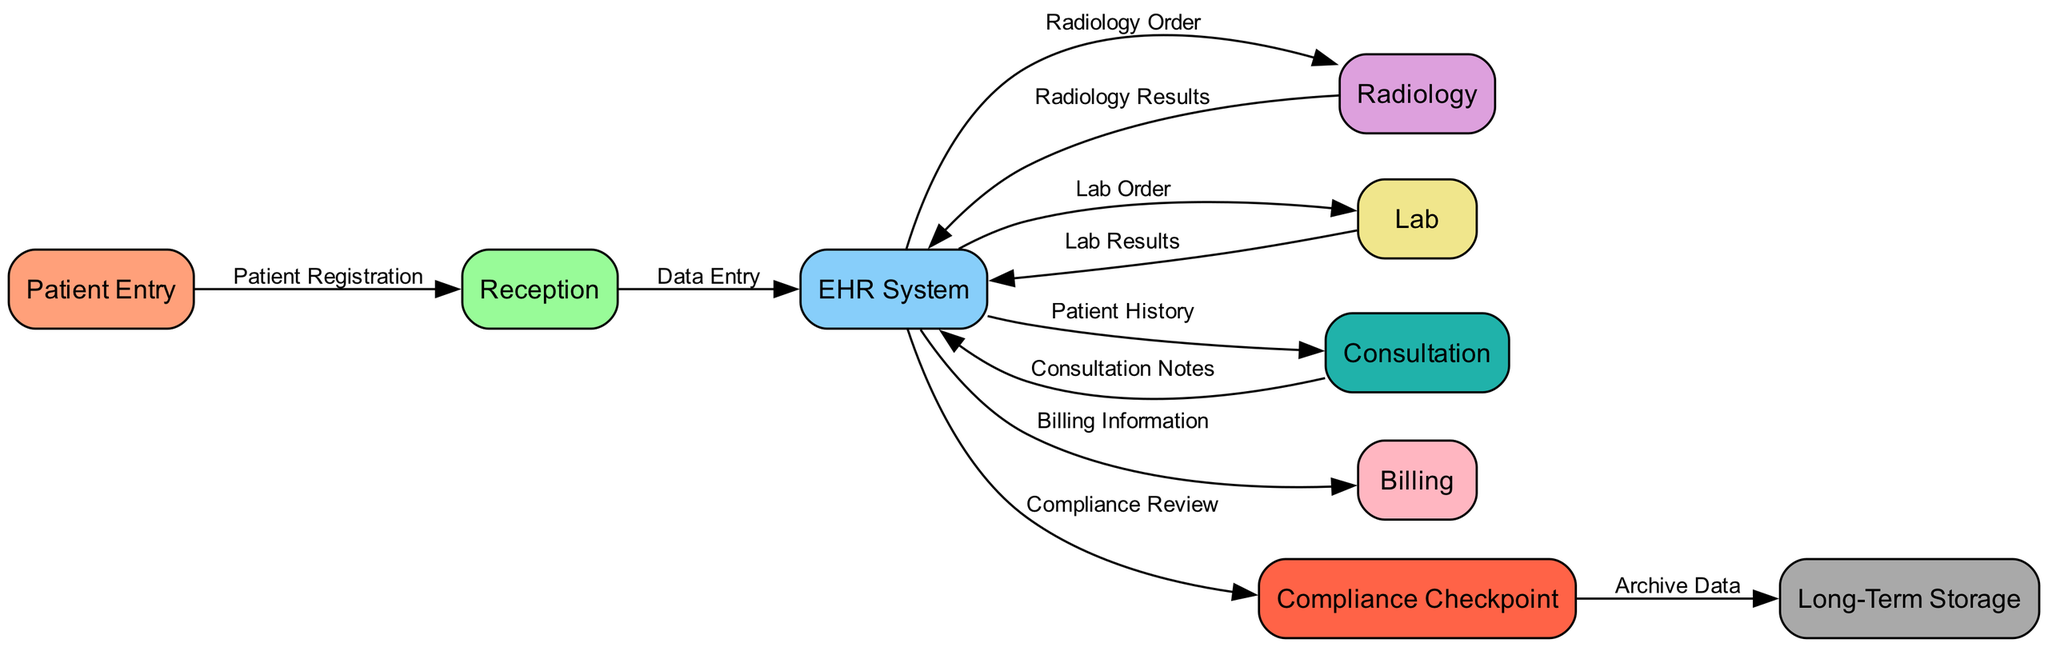What is the first step in the patient data flow? The first step is 'Patient Entry', where the patient initially interacts with the system.
Answer: Patient Entry How many total nodes are present in the diagram? There are 9 nodes listed, each representing a stage in the patient data flow.
Answer: 9 Which department is responsible for receiving and registering the patient? The 'Reception' department handles the registration process after the patient's entry.
Answer: Reception What document follows the 'Lab Order'? The 'Lab Results' come after the 'Lab Order' is processed within the system.
Answer: Lab Results What is the role of the 'Compliance Checkpoint'? The 'Compliance Checkpoint' serves to conduct a compliance review before archiving data.
Answer: Compliance Review Which node receives the 'Radiology Results'? The 'EHR System' is where the 'Radiology Results' are sent for integration and record-keeping.
Answer: EHR System What is the final destination for patient data in this workflow? The data is archived in 'Long-Term Storage' after passing through all checkpoints.
Answer: Long-Term Storage What is the relationship between 'EHR System' and 'Consultation'? The 'EHR System' provides 'Patient History' to the 'Consultation' for further assessment.
Answer: Patient History How many edges are connected to the 'EHR System'? The 'EHR System' has 5 outgoing edges connecting it to various departments and processes.
Answer: 5 What is a critical compliance requirement in the data flow? A critical requirement is the 'Compliance Checkpoint', which ensures compliance before archiving.
Answer: Compliance Checkpoint 